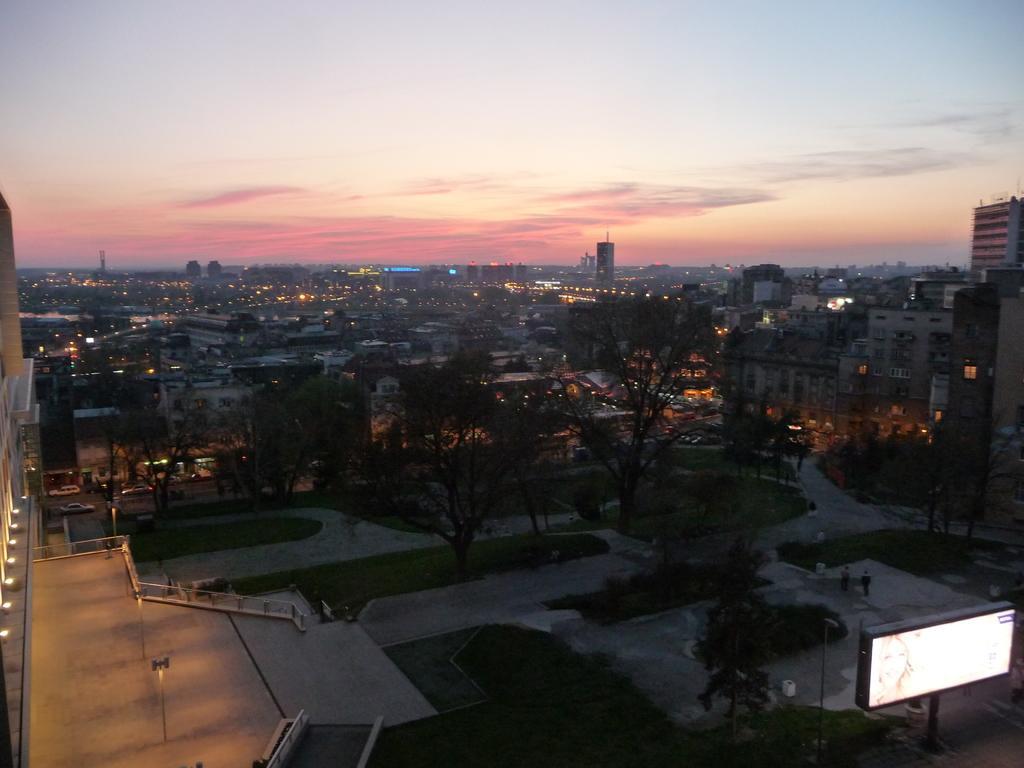Please provide a concise description of this image. This is the picture of the view of a place where we have some buildings, houses, trees, plants, roads and some things around. 